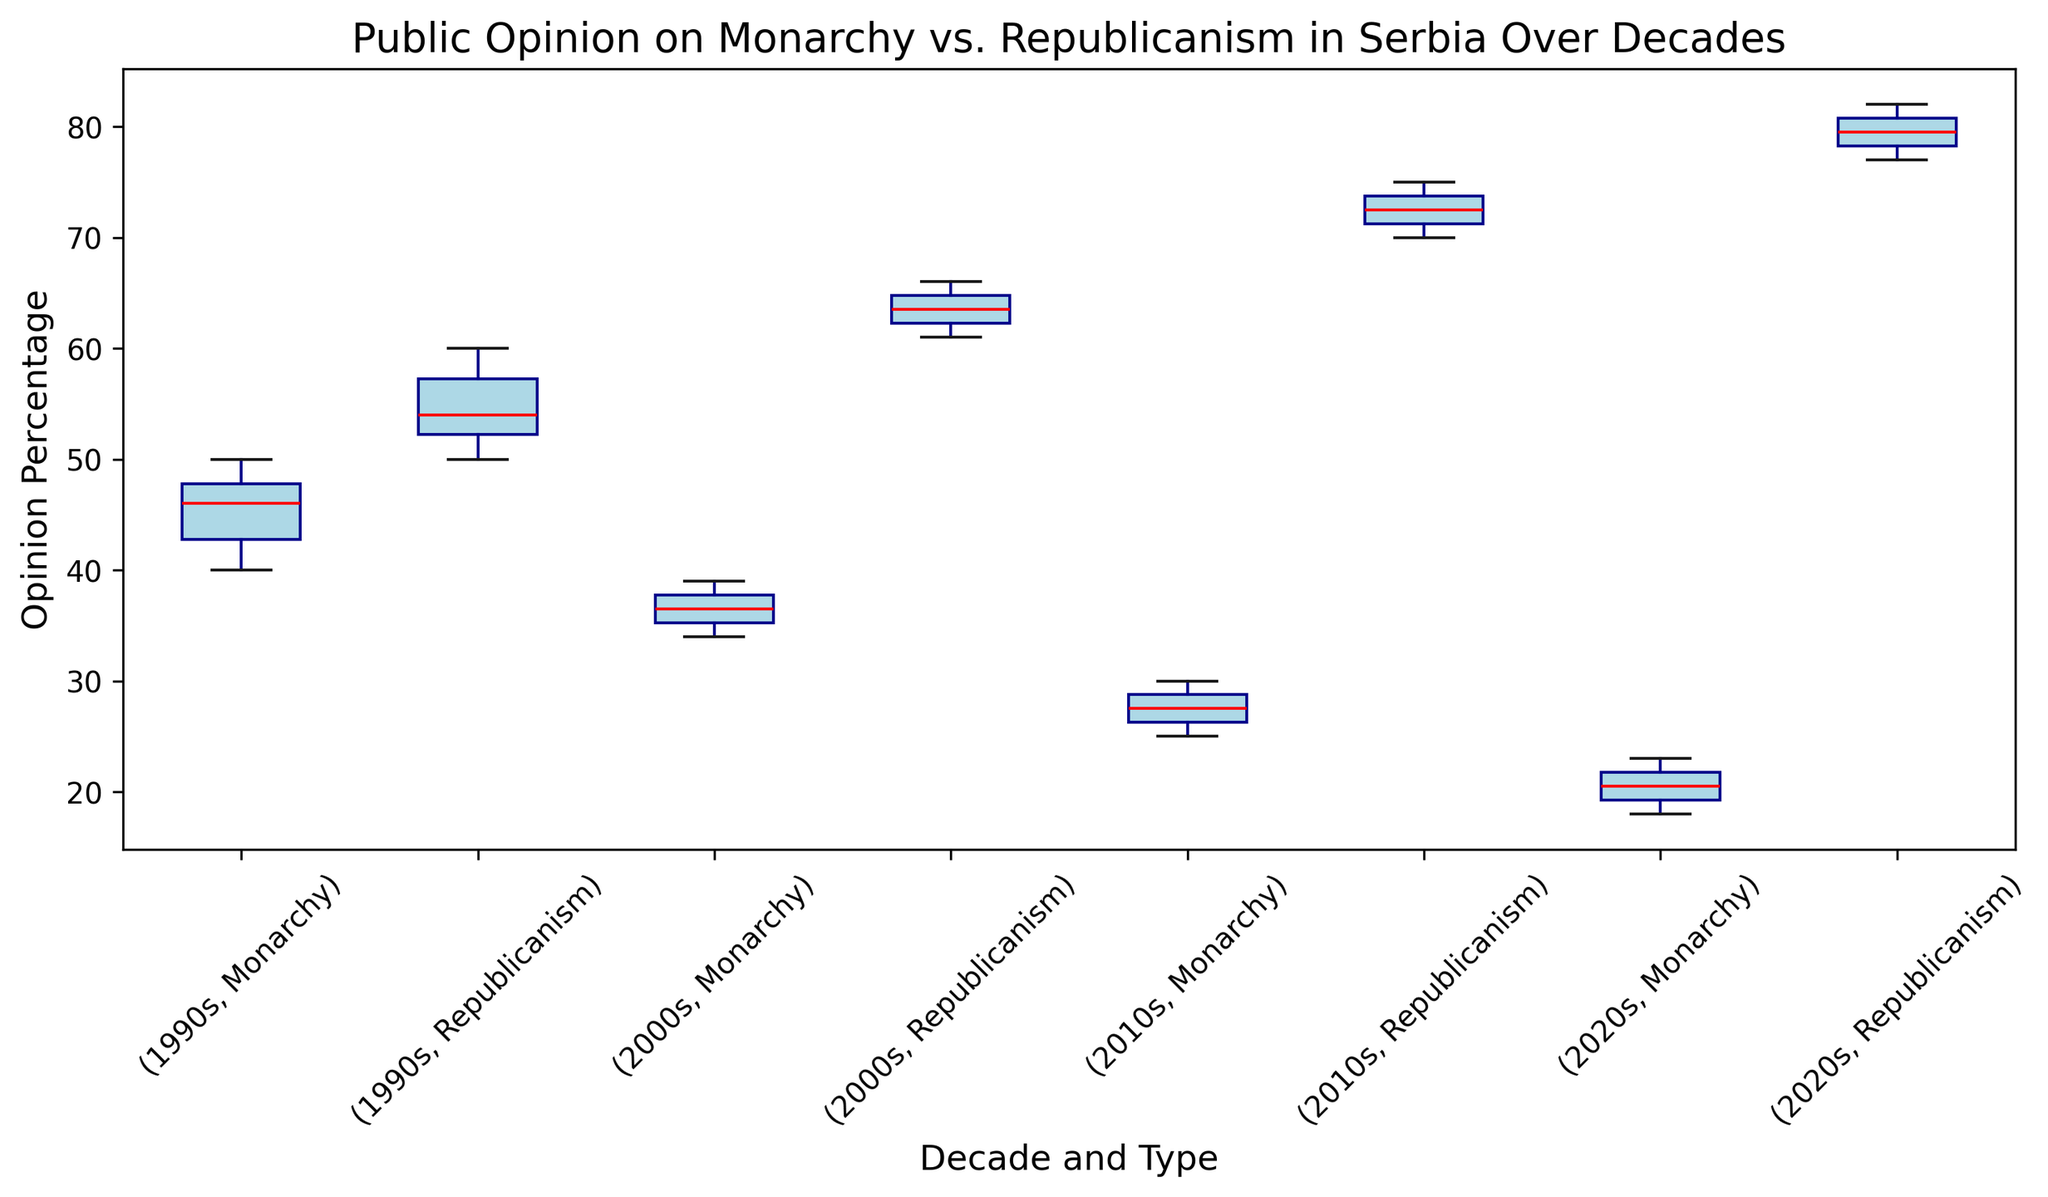Is the median opinion on monarchy higher in the 1990s or the 2010s? To determine the median opinion on monarchy, observe the red lines in each boxplot for the 1990s and the 2010s. The red median line for the 1990s is around 45%, while for the 2010s, it is around 27%. Therefore, the median opinion on monarchy is higher in the 1990s.
Answer: 1990s Which decade shows the greatest decline in public opinion towards monarchy from the previous decade? Compare the medians of the monarchy opinion across each consecutive decade. The median drops from around 45% in the 1990s to 38% in the 2000s, and then significantly to around 27% in the 2010s, and further to around 20% in the 2020s. The decline from the 1990s to the 2000s is noticeable, but the greatest decline is from the 2000s to the 2010s.
Answer: 2000s to 2010s Is the public opinion on republicanism generally increasing or decreasing over the decades? To evaluate the trend in public opinion on republicanism, observe the red median lines in the boxplots for republicanism across the decades. The median starts around 55% in the 1990s, increases to around 65% in the 2000s, rises further to around 73% in the 2010s, and remains high around 80% in the 2020s. This shows a consistent increase.
Answer: Increasing How do the interquartile ranges (IQR) of monarchy opinion compare between the 1990s and the 2020s? The interquartile range (IQR) is represented by the height of the box in the boxplot, which covers from the 25th to the 75th percentile. In the 1990s, the box for monarchy spans roughly from 42% to 48%, making the IQR approximately 6%. In the 2020s, the box spans from approximately 19% to 23%, making the IQR around 4%. The IQR for monarchy opinion is larger in the 1990s than in the 2020s.
Answer: Larger in the 1990s What is the median opinion percentage on republicanism in the 2010s? Look at the red median line within the boxplot for republicanism in the 2010s. The median opinion percentage is around 73%.
Answer: 73% Which has a generally more stable public opinion, monarchy or republicanism, over the decades? Stability can be assessed by looking at the overall spread and the variability in the boxplots for monarchy and republicanism across all decades. Republicanism boxplots show tighter boxes and less variability, indicating more stability, while monarchy boxplots show more variability in their spread.
Answer: Republicanism Which decade has the lowest median opinion percentage for monarchy? To find the lowest median opinion for monarchy, look for the boxplot with the lowest red median line among the decades. The 2020s boxplot has the lowest median, around 20%.
Answer: 2020s How does the range of opinion on republicanism in the 2000s compare to that in the 2010s? The range is the difference between the maximum and minimum values. In the 2000s, the range for republicanism is from around 61% to 66% (a 5 percentage point range). In the 2010s, the range is from around 71% to 75% (a 4 percentage point range). The range is slightly wider in the 2000s.
Answer: Wider in the 2000s 